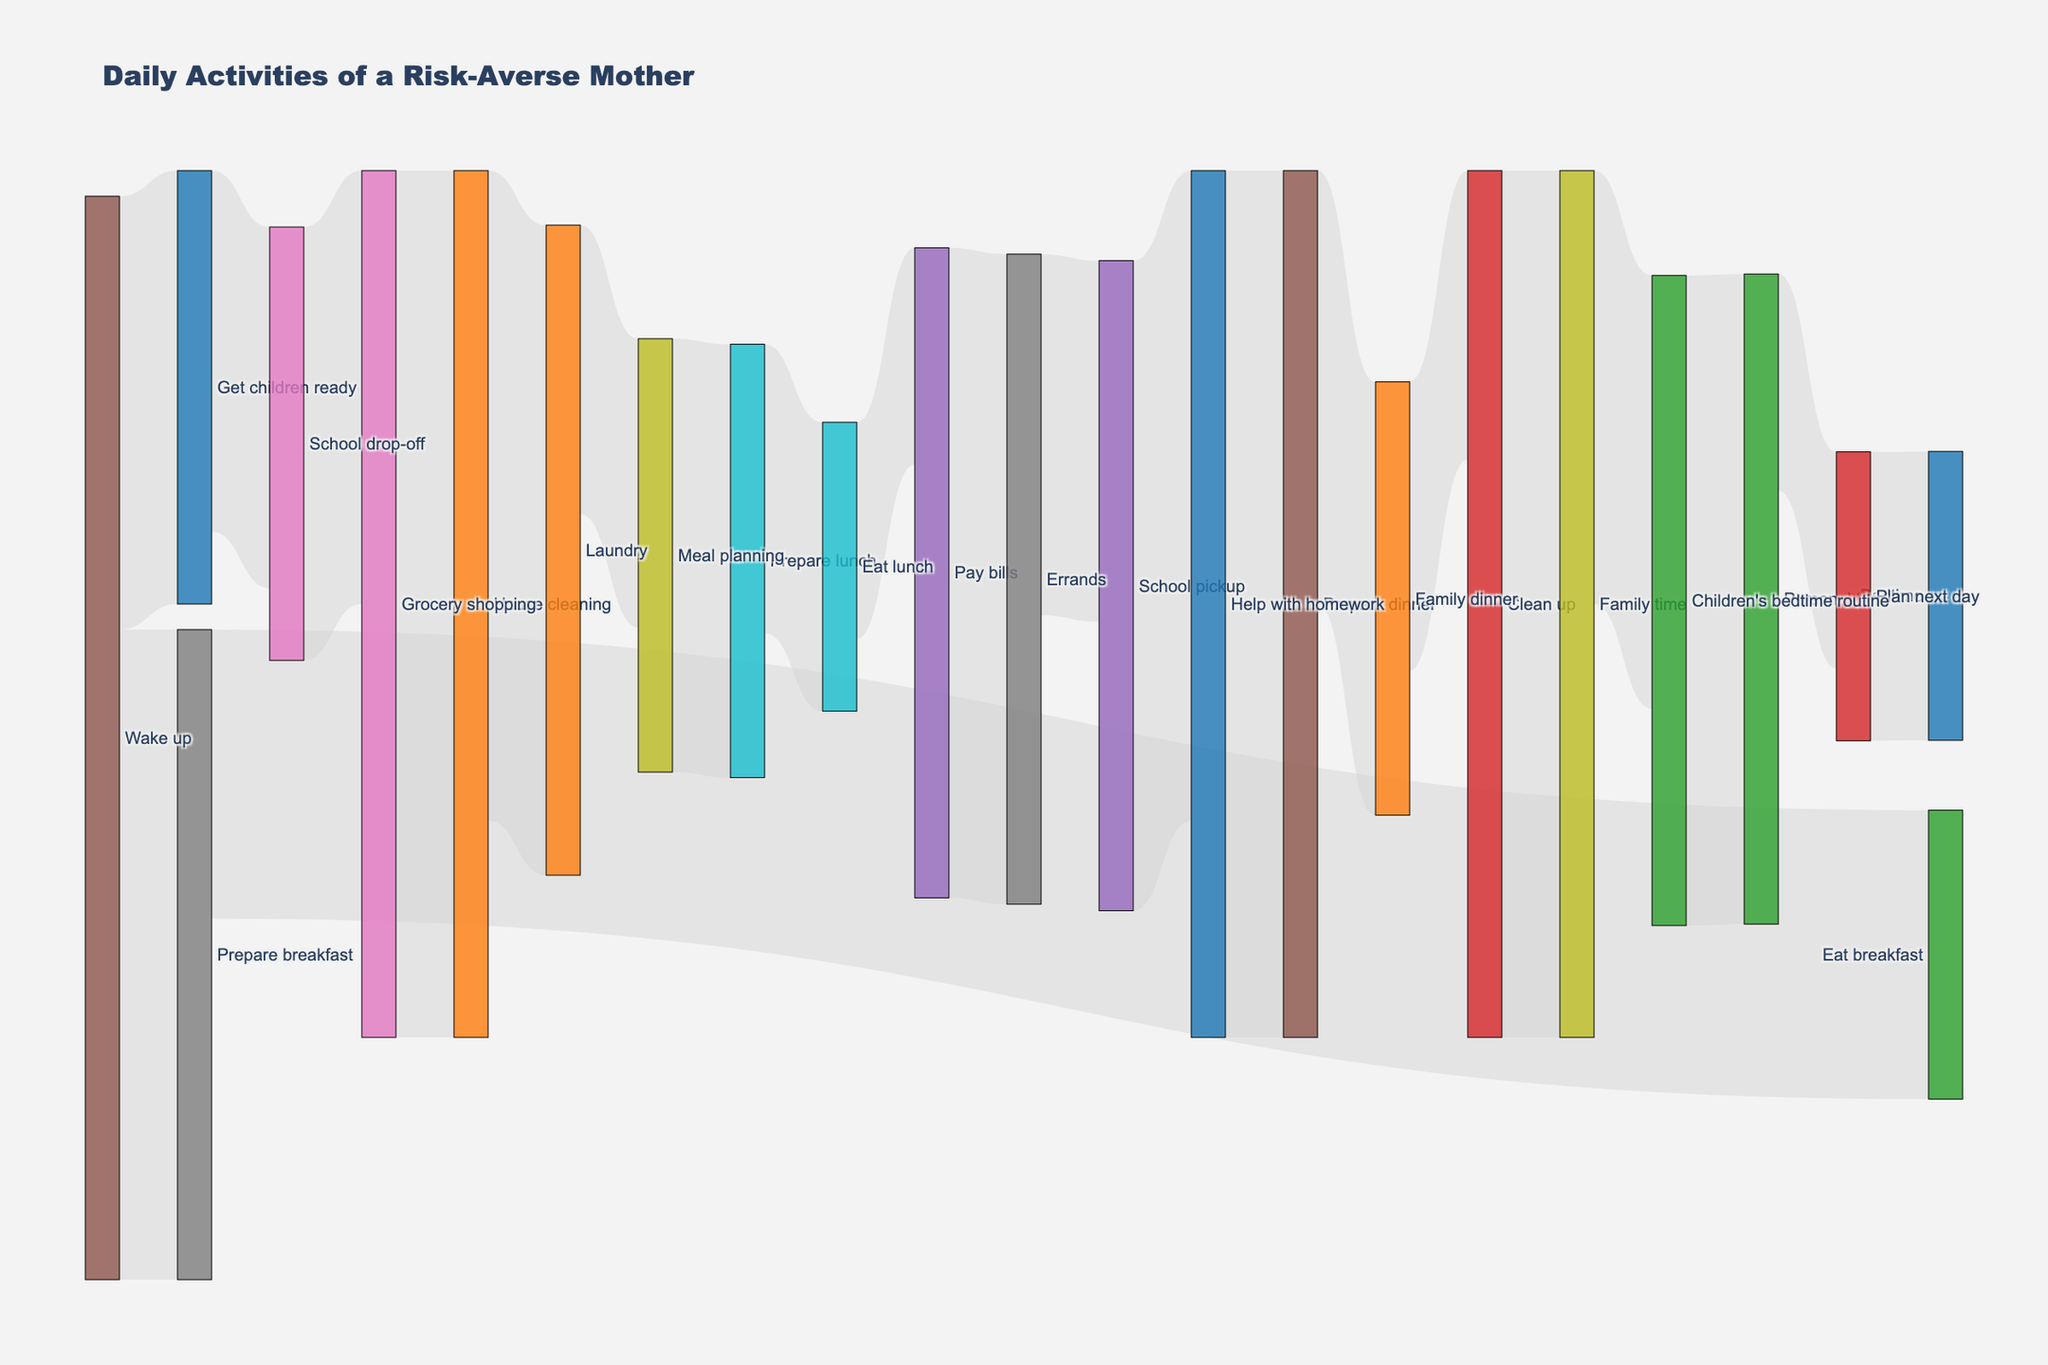What's the most time-consuming activity before the school drop-off? To determine this, look at the segments leading to "School drop-off" and identify the one with the highest value. "Wake up" leads to "Prepare breakfast" (45 minutes) and "Get children ready" (30 minutes). "Prepare breakfast" leads to "Eat breakfast" (20 minutes), and "Get children ready" leads to "School drop-off" (25 minutes). The longest activity before "School drop-off" is "Prepare breakfast" at 45 minutes.
Answer: Prepare breakfast How much time in total is dedicated to meal-related activities (preparing and eating)? To find the total time for meal-related activities, locate the segments related to meal preparation and eating: "Prepare breakfast" (45 minutes), "Eat breakfast" (20 minutes), "Prepare lunch" (30 minutes), "Eat lunch" (20 minutes), "Prepare dinner" (60 minutes), and "Family dinner" (30 minutes). Sum these values: 45 + 20 + 30 + 20 + 60 + 30 = 205 minutes.
Answer: 205 minutes Which activity has the longest continuous time from one task to another? Continuous time is the sum of consecutive tasks' values. First, check the longest individual and combined segments: - "House cleaning" to "Laundry" is 60 + 45 = 105 minutes - "Help with homework" to "Prepare dinner" is 45 + 60 = 105 minutes. Compare these with other segments. These are equal, both at 105 minutes.
Answer: House cleaning to Laundry/ Help with homework to Prepare dinner What's the difference in time between "Meal planning" and "Plan next day"? Look for the durations directly labeled “Meal planning” (20 minutes) and “Plan next day” (15 minutes). Calculate the difference: 20 - 15 = 5 minutes.
Answer: 5 minutes How much time is spent on errand-related activities, including school drop-off and pickup? Find durations for “School drop-off” (25 minutes), “Grocery shopping” (30 minutes), “Errands” (45 minutes), and “School pickup” (25 minutes). Sum these values: 25 + 30 + 45 + 25 = 125 minutes.
Answer: 125 minutes Which activities are directly followed by Family time? Check segments leading to “Family time.” Only "Clean up" directs to “Family time,” which is a 60-minute activity.
Answer: Clean up Which activity directly precedes the children's bedtime routine? The segment leading to “Children's bedtime routine” is “Family time” (60 minutes).
Answer: Family time How much time is spent on household chores including grocery shopping, house cleaning, and laundry? Household chores are "Grocery shopping" (30 minutes), "House cleaning" (60 minutes), and "Laundry" (45 minutes). Sum these values: 30 + 60 + 45 = 135 minutes.
Answer: 135 minutes How much personal time does the mother have throughout the day? Identify segments related to personal time. "Personal time" (45 minutes) and "Plan next day" (15 minutes). Sum these values: 45 + 15 = 60 minutes.
Answer: 60 minutes 